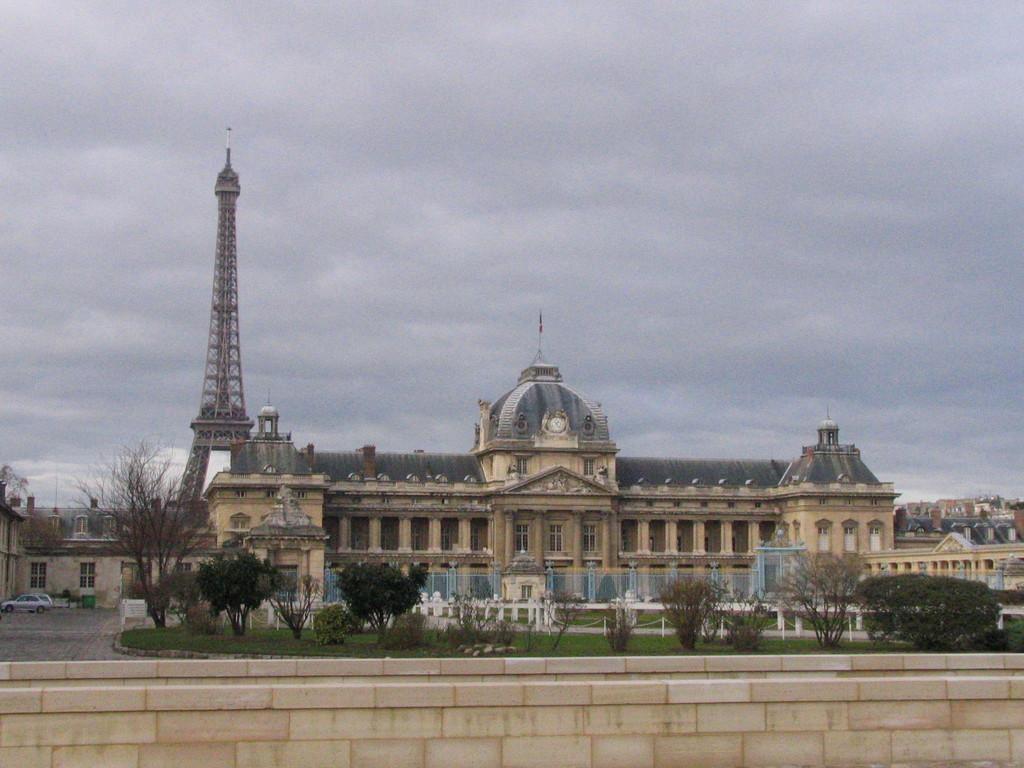Could you give a brief overview of what you see in this image? In this picture I can see the buildings, trees, plants, grass, monument and Eiffel tower. At the top of the dome there is a flag. At the bottom I can see the wall partition. At the top I can see the sky and clouds. On the left I can see some cars which are parked near to the building. 